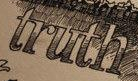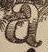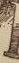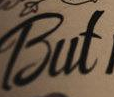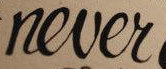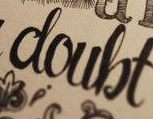Identify the words shown in these images in order, separated by a semicolon. truth; a; #; But; never; doubt 